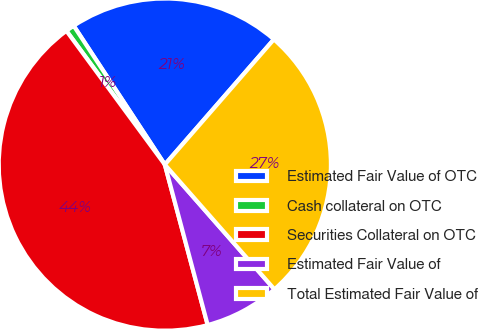Convert chart to OTSL. <chart><loc_0><loc_0><loc_500><loc_500><pie_chart><fcel>Estimated Fair Value of OTC<fcel>Cash collateral on OTC<fcel>Securities Collateral on OTC<fcel>Estimated Fair Value of<fcel>Total Estimated Fair Value of<nl><fcel>20.65%<fcel>0.85%<fcel>44.06%<fcel>7.32%<fcel>27.12%<nl></chart> 